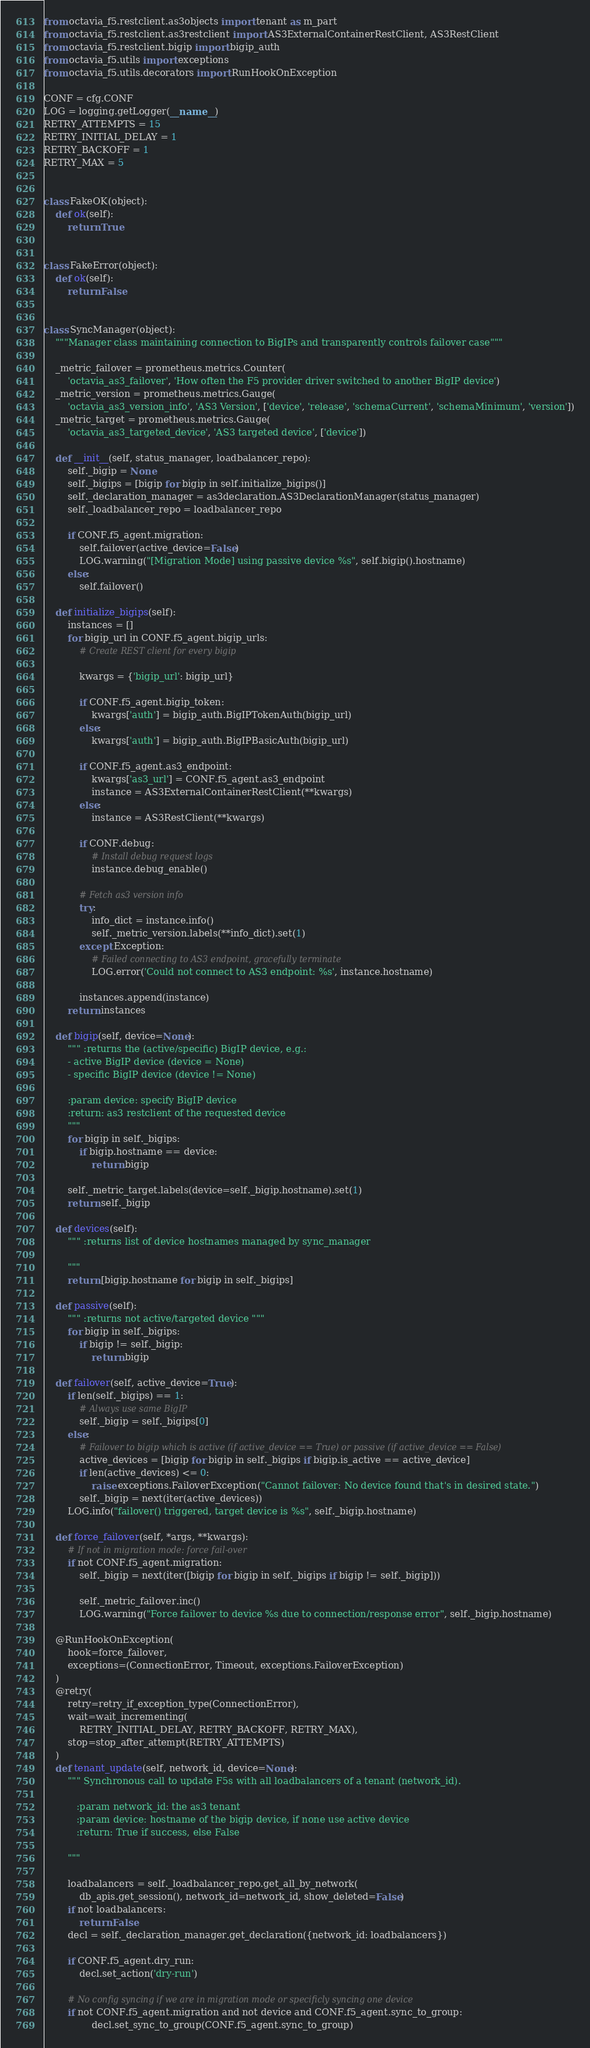<code> <loc_0><loc_0><loc_500><loc_500><_Python_>from octavia_f5.restclient.as3objects import tenant as m_part
from octavia_f5.restclient.as3restclient import AS3ExternalContainerRestClient, AS3RestClient
from octavia_f5.restclient.bigip import bigip_auth
from octavia_f5.utils import exceptions
from octavia_f5.utils.decorators import RunHookOnException

CONF = cfg.CONF
LOG = logging.getLogger(__name__)
RETRY_ATTEMPTS = 15
RETRY_INITIAL_DELAY = 1
RETRY_BACKOFF = 1
RETRY_MAX = 5


class FakeOK(object):
    def ok(self):
        return True


class FakeError(object):
    def ok(self):
        return False


class SyncManager(object):
    """Manager class maintaining connection to BigIPs and transparently controls failover case"""

    _metric_failover = prometheus.metrics.Counter(
        'octavia_as3_failover', 'How often the F5 provider driver switched to another BigIP device')
    _metric_version = prometheus.metrics.Gauge(
        'octavia_as3_version_info', 'AS3 Version', ['device', 'release', 'schemaCurrent', 'schemaMinimum', 'version'])
    _metric_target = prometheus.metrics.Gauge(
        'octavia_as3_targeted_device', 'AS3 targeted device', ['device'])

    def __init__(self, status_manager, loadbalancer_repo):
        self._bigip = None
        self._bigips = [bigip for bigip in self.initialize_bigips()]
        self._declaration_manager = as3declaration.AS3DeclarationManager(status_manager)
        self._loadbalancer_repo = loadbalancer_repo

        if CONF.f5_agent.migration:
            self.failover(active_device=False)
            LOG.warning("[Migration Mode] using passive device %s", self.bigip().hostname)
        else:
            self.failover()

    def initialize_bigips(self):
        instances = []
        for bigip_url in CONF.f5_agent.bigip_urls:
            # Create REST client for every bigip

            kwargs = {'bigip_url': bigip_url}

            if CONF.f5_agent.bigip_token:
                kwargs['auth'] = bigip_auth.BigIPTokenAuth(bigip_url)
            else:
                kwargs['auth'] = bigip_auth.BigIPBasicAuth(bigip_url)

            if CONF.f5_agent.as3_endpoint:
                kwargs['as3_url'] = CONF.f5_agent.as3_endpoint
                instance = AS3ExternalContainerRestClient(**kwargs)
            else:
                instance = AS3RestClient(**kwargs)

            if CONF.debug:
                # Install debug request logs
                instance.debug_enable()

            # Fetch as3 version info
            try:
                info_dict = instance.info()
                self._metric_version.labels(**info_dict).set(1)
            except Exception:
                # Failed connecting to AS3 endpoint, gracefully terminate
                LOG.error('Could not connect to AS3 endpoint: %s', instance.hostname)

            instances.append(instance)
        return instances

    def bigip(self, device=None):
        """ :returns the (active/specific) BigIP device, e.g.:
        - active BigIP device (device = None)
        - specific BigIP device (device != None)

        :param device: specify BigIP device
        :return: as3 restclient of the requested device
        """
        for bigip in self._bigips:
            if bigip.hostname == device:
                return bigip

        self._metric_target.labels(device=self._bigip.hostname).set(1)
        return self._bigip

    def devices(self):
        """ :returns list of device hostnames managed by sync_manager

        """
        return [bigip.hostname for bigip in self._bigips]

    def passive(self):
        """ :returns not active/targeted device """
        for bigip in self._bigips:
            if bigip != self._bigip:
                return bigip

    def failover(self, active_device=True):
        if len(self._bigips) == 1:
            # Always use same BigIP
            self._bigip = self._bigips[0]
        else:
            # Failover to bigip which is active (if active_device == True) or passive (if active_device == False)
            active_devices = [bigip for bigip in self._bigips if bigip.is_active == active_device]
            if len(active_devices) <= 0:
                raise exceptions.FailoverException("Cannot failover: No device found that's in desired state.")
            self._bigip = next(iter(active_devices))
        LOG.info("failover() triggered, target device is %s", self._bigip.hostname)

    def force_failover(self, *args, **kwargs):
        # If not in migration mode: force fail-over
        if not CONF.f5_agent.migration:
            self._bigip = next(iter([bigip for bigip in self._bigips if bigip != self._bigip]))

            self._metric_failover.inc()
            LOG.warning("Force failover to device %s due to connection/response error", self._bigip.hostname)

    @RunHookOnException(
        hook=force_failover,
        exceptions=(ConnectionError, Timeout, exceptions.FailoverException)
    )
    @retry(
        retry=retry_if_exception_type(ConnectionError),
        wait=wait_incrementing(
            RETRY_INITIAL_DELAY, RETRY_BACKOFF, RETRY_MAX),
        stop=stop_after_attempt(RETRY_ATTEMPTS)
    )
    def tenant_update(self, network_id, device=None):
        """ Synchronous call to update F5s with all loadbalancers of a tenant (network_id).

           :param network_id: the as3 tenant
           :param device: hostname of the bigip device, if none use active device
           :return: True if success, else False

        """

        loadbalancers = self._loadbalancer_repo.get_all_by_network(
            db_apis.get_session(), network_id=network_id, show_deleted=False)
        if not loadbalancers:
            return False
        decl = self._declaration_manager.get_declaration({network_id: loadbalancers})

        if CONF.f5_agent.dry_run:
            decl.set_action('dry-run')

        # No config syncing if we are in migration mode or specificly syncing one device
        if not CONF.f5_agent.migration and not device and CONF.f5_agent.sync_to_group:
                decl.set_sync_to_group(CONF.f5_agent.sync_to_group)
</code> 